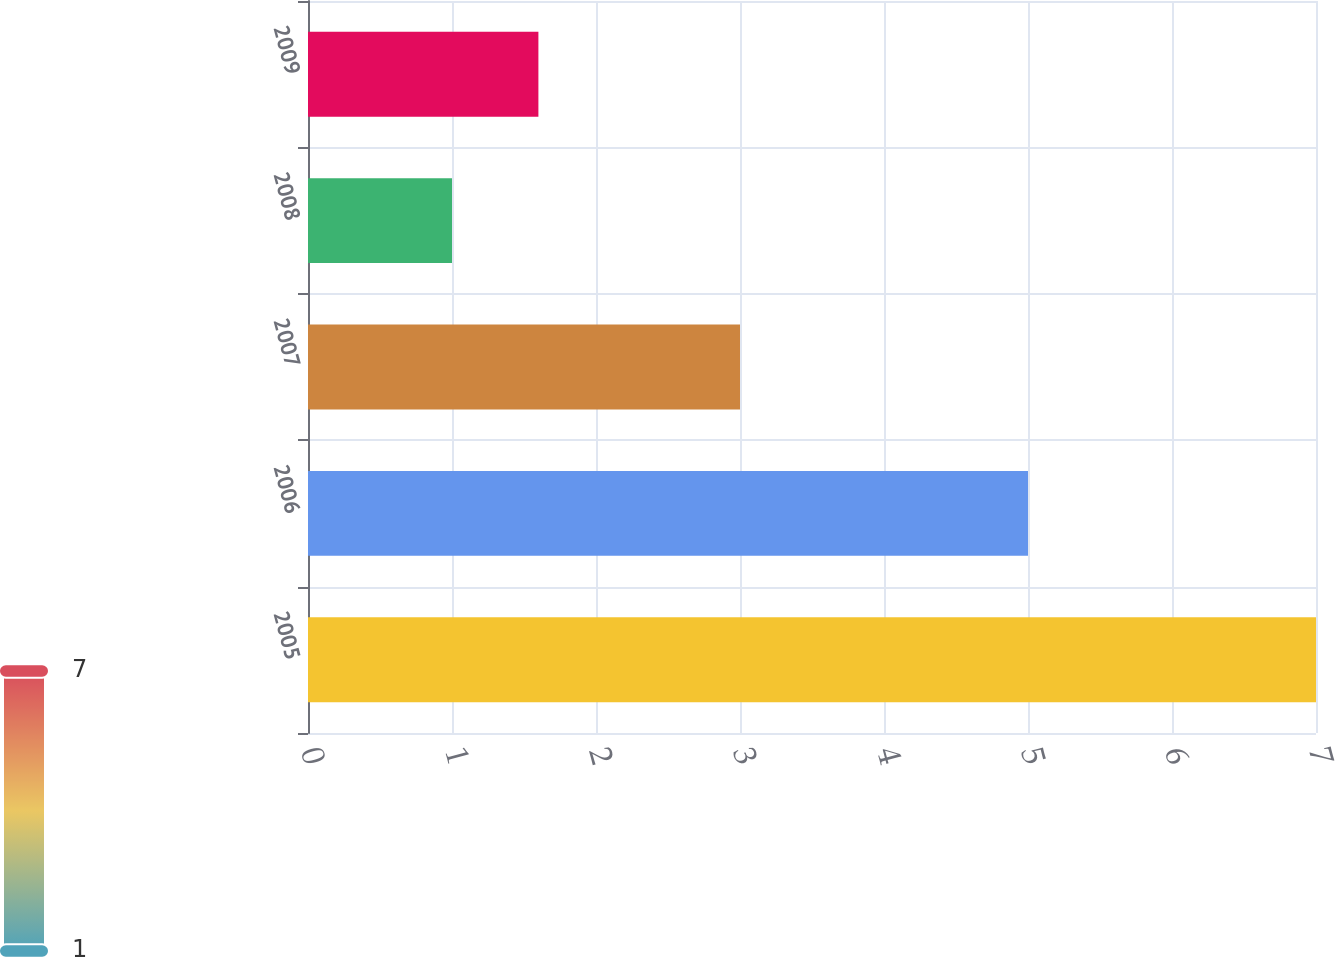Convert chart to OTSL. <chart><loc_0><loc_0><loc_500><loc_500><bar_chart><fcel>2005<fcel>2006<fcel>2007<fcel>2008<fcel>2009<nl><fcel>7<fcel>5<fcel>3<fcel>1<fcel>1.6<nl></chart> 